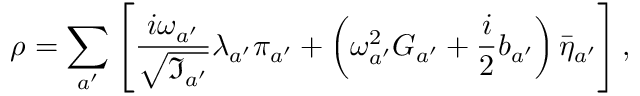<formula> <loc_0><loc_0><loc_500><loc_500>\rho = \sum _ { a ^ { \prime } } \left [ \frac { i \omega _ { a ^ { \prime } } } { \sqrt { \Im _ { a ^ { \prime } } } } \lambda _ { a ^ { \prime } } \pi _ { a ^ { \prime } } + \left ( \omega _ { a ^ { \prime } } ^ { 2 } G _ { a ^ { \prime } } + \frac { i } { 2 } b _ { a ^ { \prime } } \right ) \bar { \eta } _ { a ^ { \prime } } \right ] ,</formula> 